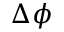<formula> <loc_0><loc_0><loc_500><loc_500>\Delta \phi</formula> 